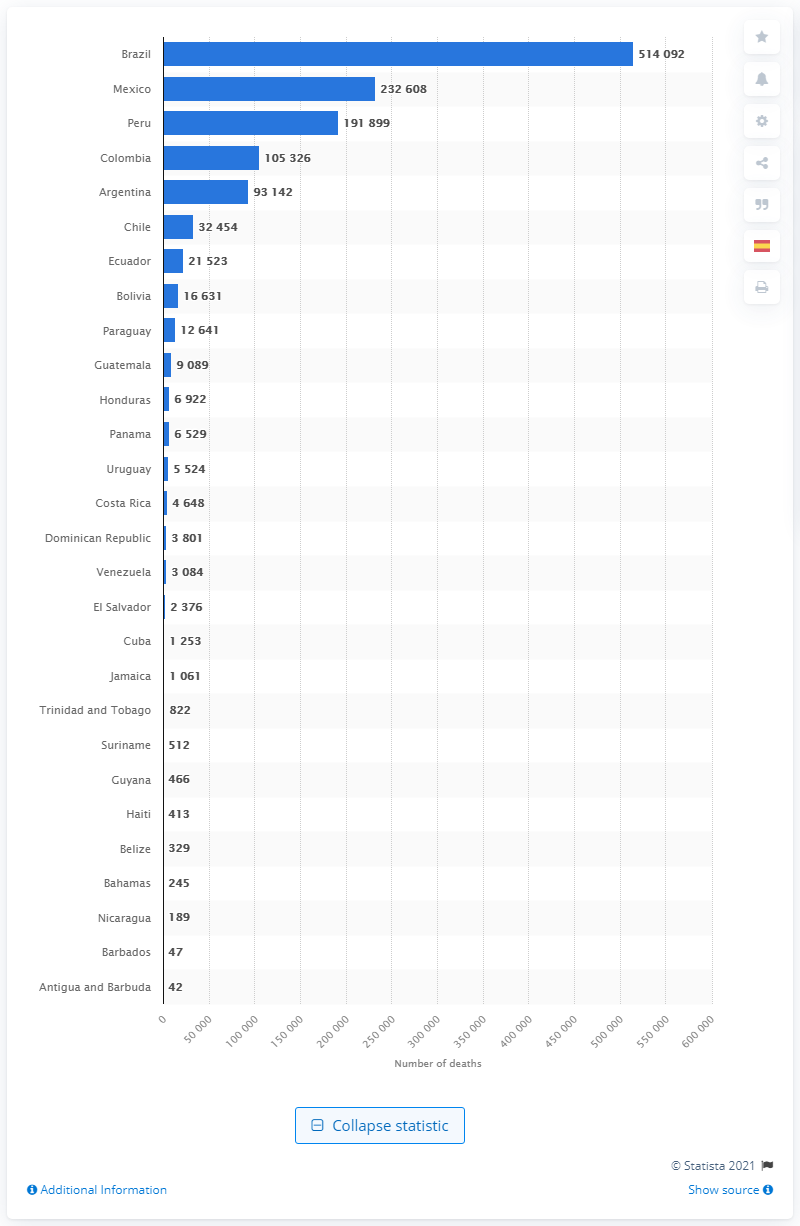Draw attention to some important aspects in this diagram. Brazil's GDP is expected to decrease by a certain amount in 2020. As of June 2021, Brazil had a reported number of deaths totaling 514,092. In 2021, there were 232,608 reported deaths in Mexico. 